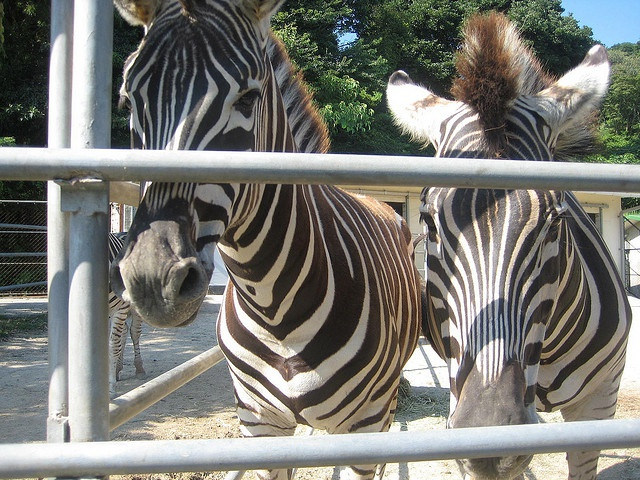Describe the objects in this image and their specific colors. I can see zebra in black, gray, and darkgray tones, zebra in black, gray, darkgray, and white tones, and zebra in black, gray, and darkgray tones in this image. 